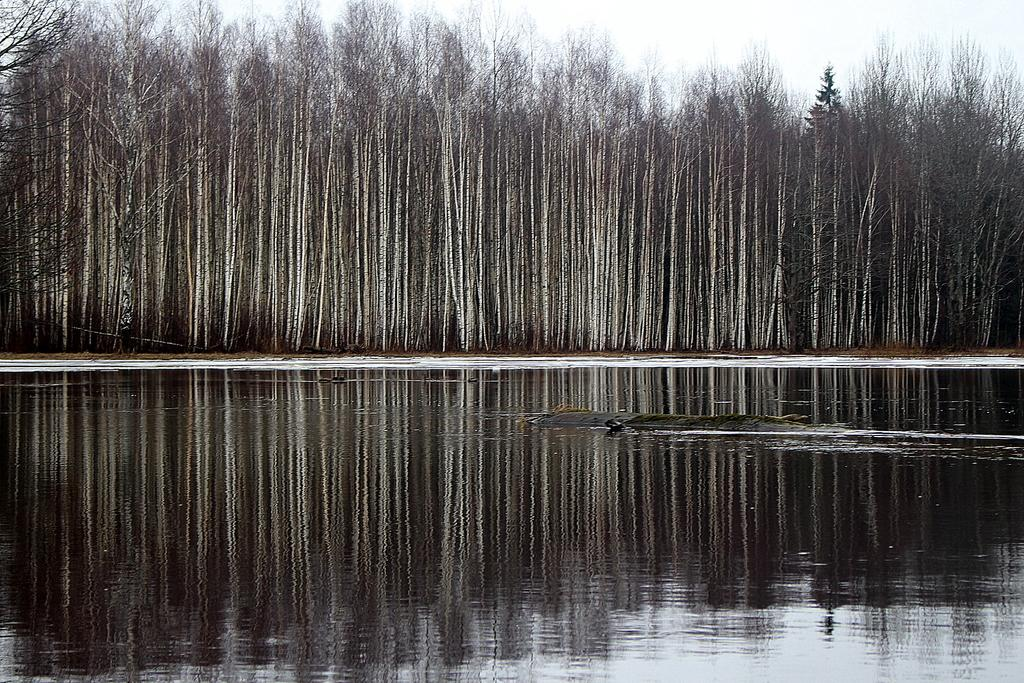What animal is in the water in the image? There is a crocodile in the water in the image. What type of vegetation can be seen in the image? There are trees visible in the image. What type of watch can be seen on the crocodile's wrist in the image? There is no watch visible on the crocodile's wrist in the image, as crocodiles do not wear watches. 